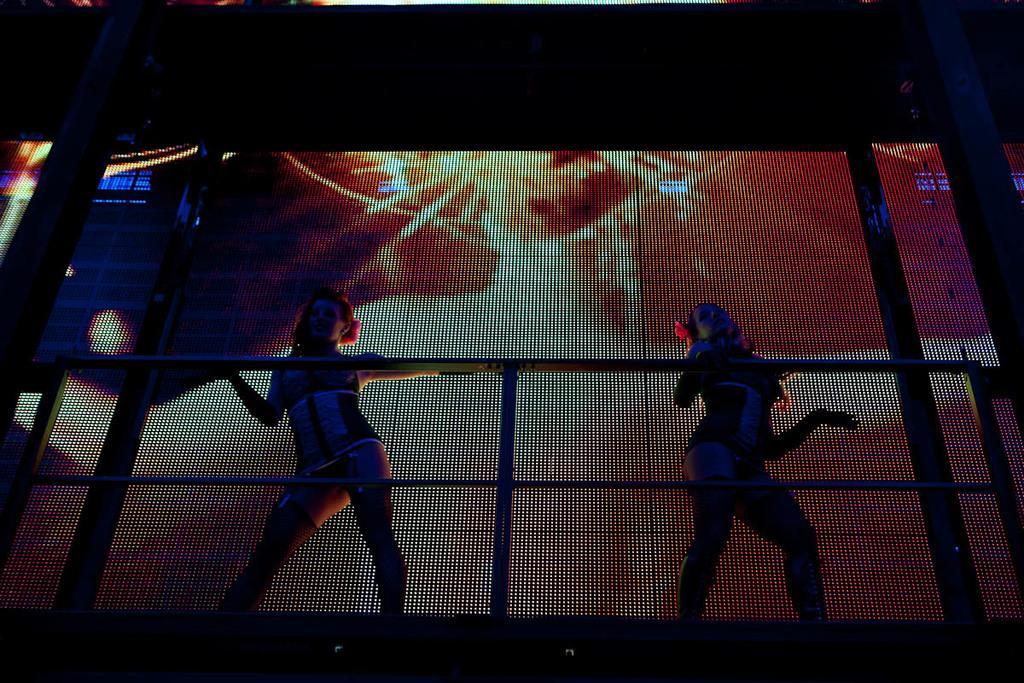Describe this image in one or two sentences. In this image, we can see people performing dance and there are railings. In the background, there are screens with some effects. 